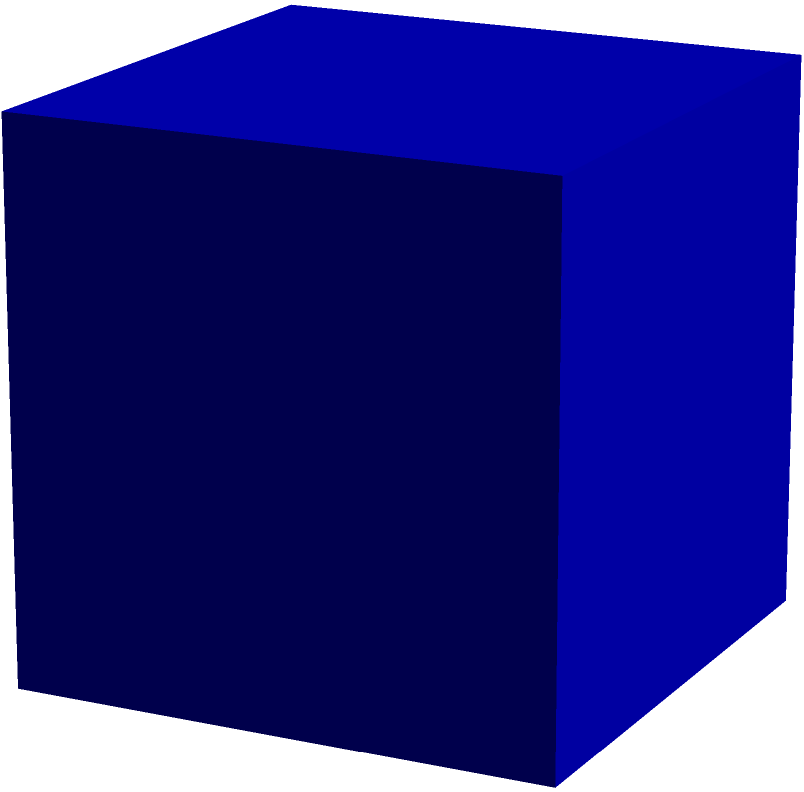You are tasked with creating an R function to calculate the surface area of a cube given its side length. Using R's 3D visualization capabilities, you need to plot the cube and display its surface area. If the side length of the cube is 2 units, what would be the surface area calculated by your function? To solve this problem, we'll follow these steps:

1. Understand the formula for the surface area of a cube:
   The surface area of a cube is given by the formula: $A = 6s^2$, where $s$ is the side length.

2. Calculate the surface area for a cube with side length 2:
   $A = 6 \cdot 2^2 = 6 \cdot 4 = 24$ square units

3. Implement the function in R:
   ```R
   calculate_cube_surface_area <- function(side_length) {
     surface_area <- 6 * side_length^2
     return(surface_area)
   }
   ```

4. Use R's 3D visualization to plot the cube:
   ```R
   library(rgl)
   plot_cube <- function(side_length) {
     cube <- cube3d(col = "blue", alpha = 0.5)
     scaled_cube <- scale3d(cube, side_length, side_length, side_length)
     plot3d(scaled_cube)
     title3d(main = paste("Cube Surface Area:", calculate_cube_surface_area(side_length)))
   }
   ```

5. Call the function with side length 2:
   ```R
   plot_cube(2)
   ```

This will create a 3D plot of the cube with side length 2 and display its surface area.
Answer: 24 square units 